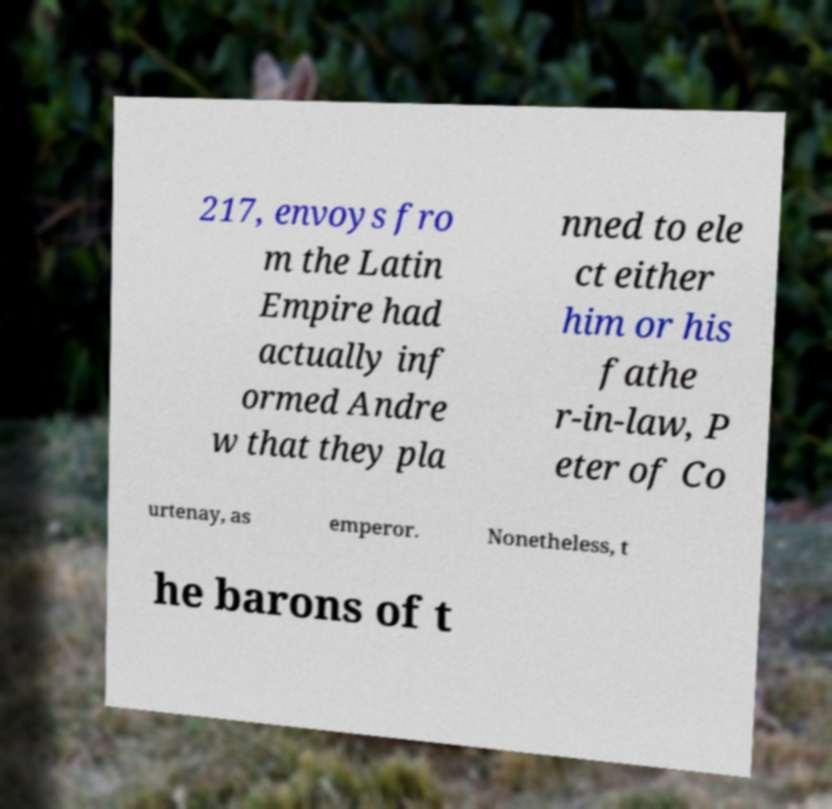There's text embedded in this image that I need extracted. Can you transcribe it verbatim? 217, envoys fro m the Latin Empire had actually inf ormed Andre w that they pla nned to ele ct either him or his fathe r-in-law, P eter of Co urtenay, as emperor. Nonetheless, t he barons of t 